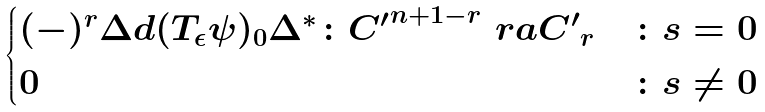Convert formula to latex. <formula><loc_0><loc_0><loc_500><loc_500>\begin{cases} ( - ) ^ { r } \Delta d ( T _ { \epsilon } \psi ) _ { 0 } \Delta ^ { * } \colon { C ^ { \prime } } ^ { n + 1 - r } \ r a { C ^ { \prime } } _ { r } & \colon s = 0 \\ 0 & \colon s \neq 0 \end{cases}</formula> 